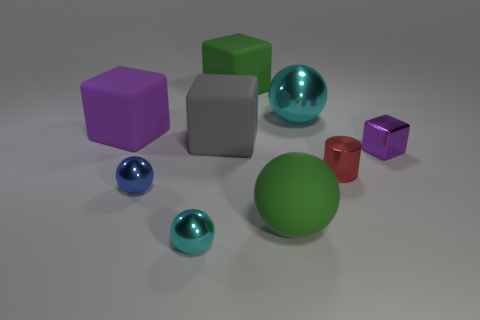The block on the right side of the cyan metal sphere that is to the right of the green object behind the tiny blue metal object is what color?
Your response must be concise. Purple. Is there a tiny cyan object behind the purple cube in front of the large purple cube?
Provide a short and direct response. No. There is a big metallic thing on the right side of the large purple matte thing; does it have the same color as the small metal object to the right of the tiny red thing?
Keep it short and to the point. No. What number of spheres have the same size as the gray cube?
Your response must be concise. 2. Do the cyan metallic object left of the gray block and the green sphere have the same size?
Provide a succinct answer. No. What is the shape of the big cyan metal thing?
Keep it short and to the point. Sphere. What size is the shiny thing that is the same color as the large metal ball?
Your answer should be compact. Small. Does the cyan thing left of the big cyan sphere have the same material as the small cylinder?
Your response must be concise. Yes. Is there another matte cube that has the same color as the tiny cube?
Give a very brief answer. Yes. There is a cyan thing that is behind the big gray rubber object; is its shape the same as the green object that is in front of the large cyan metallic object?
Your response must be concise. Yes. 